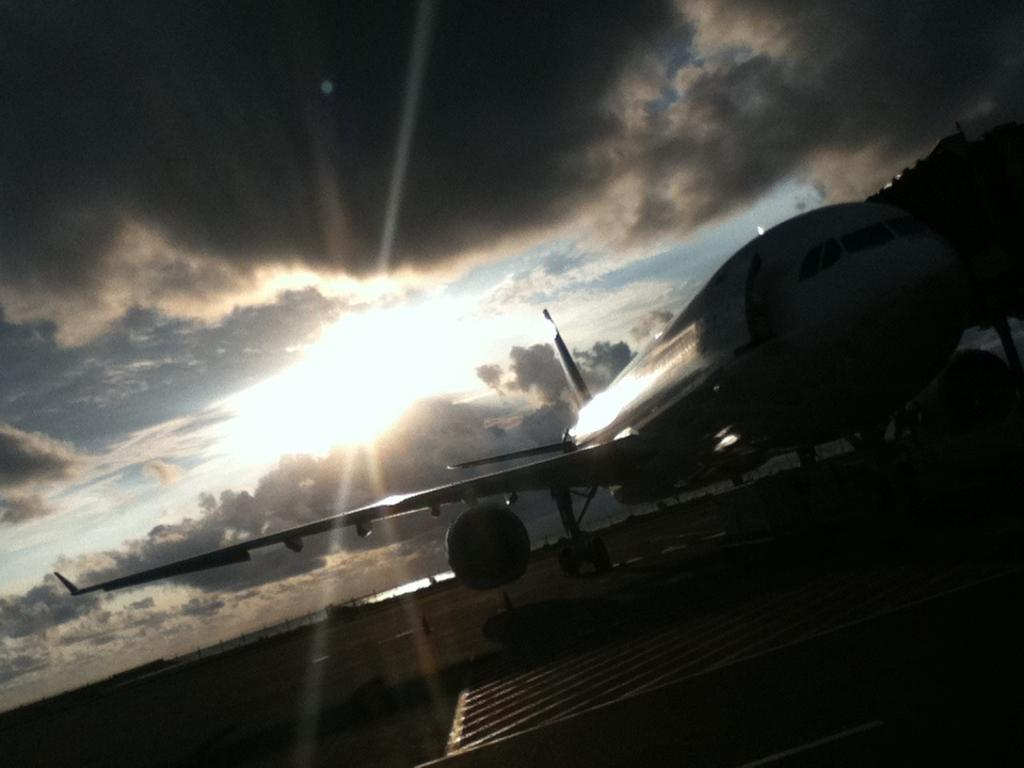What is the main subject of the image? The main subject of the image is an aircraft. Where is the aircraft located in the image? The aircraft is on the ground in the image. What can be seen in the sky in the background of the image? There are clouds visible in the sky in the background of the image. What type of map is the girl holding while standing next to the aircraft in the image? There is no girl or map present in the image; it only features an aircraft on the ground with clouds in the sky in the background. 